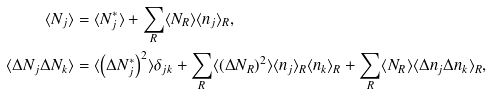Convert formula to latex. <formula><loc_0><loc_0><loc_500><loc_500>\langle N _ { j } \rangle & = \langle N _ { j } ^ { * } \rangle + \sum _ { R } \langle N _ { R } \rangle \langle n _ { j } \rangle _ { R } , \\ \langle \Delta N _ { j } \Delta N _ { k } \rangle & = \langle \left ( \Delta N _ { j } ^ { * } \right ) ^ { 2 } \rangle \delta _ { j k } + \sum _ { R } \langle ( \Delta N _ { R } ) ^ { 2 } \rangle \langle n _ { j } \rangle _ { R } \langle n _ { k } \rangle _ { R } + \sum _ { R } \langle N _ { R } \rangle \langle \Delta n _ { j } \Delta n _ { k } \rangle _ { R } ,</formula> 